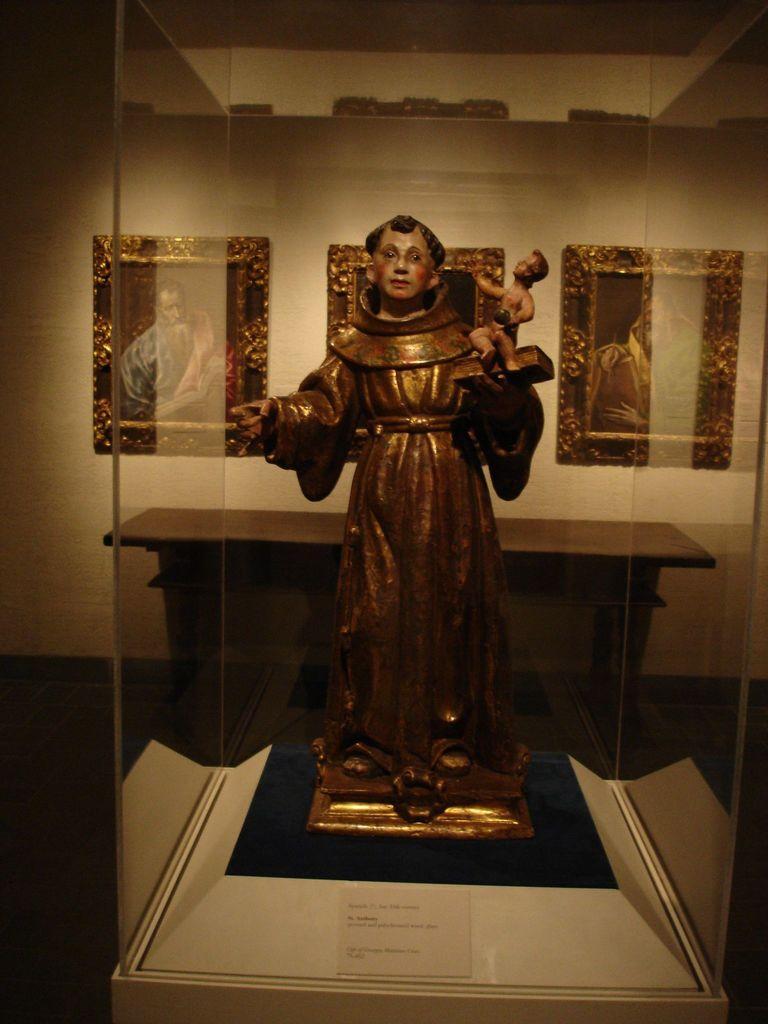Describe this image in one or two sentences. In this image I can see a glass box and in the box I can see a statue of a person. In the background I can see the wall and few photo frames attached to the wall. 